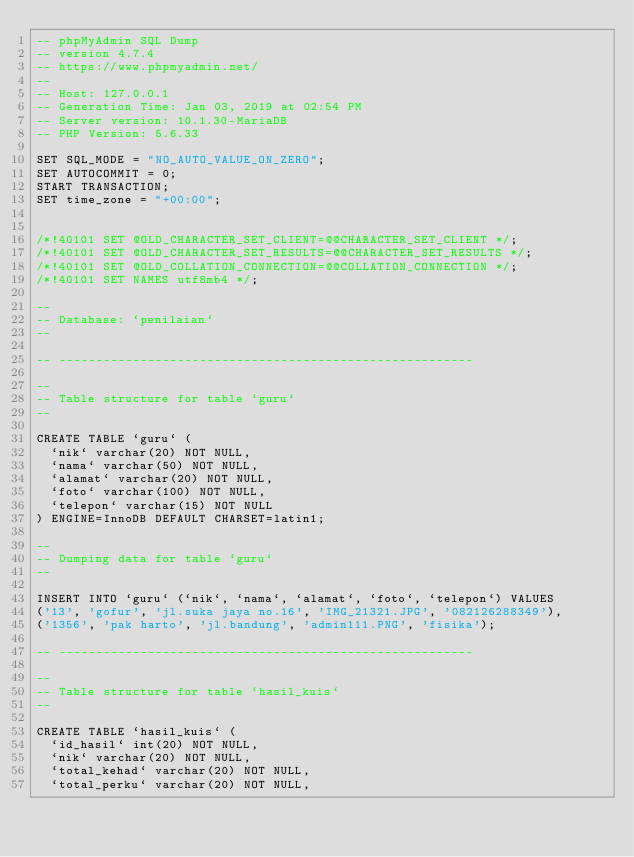Convert code to text. <code><loc_0><loc_0><loc_500><loc_500><_SQL_>-- phpMyAdmin SQL Dump
-- version 4.7.4
-- https://www.phpmyadmin.net/
--
-- Host: 127.0.0.1
-- Generation Time: Jan 03, 2019 at 02:54 PM
-- Server version: 10.1.30-MariaDB
-- PHP Version: 5.6.33

SET SQL_MODE = "NO_AUTO_VALUE_ON_ZERO";
SET AUTOCOMMIT = 0;
START TRANSACTION;
SET time_zone = "+00:00";


/*!40101 SET @OLD_CHARACTER_SET_CLIENT=@@CHARACTER_SET_CLIENT */;
/*!40101 SET @OLD_CHARACTER_SET_RESULTS=@@CHARACTER_SET_RESULTS */;
/*!40101 SET @OLD_COLLATION_CONNECTION=@@COLLATION_CONNECTION */;
/*!40101 SET NAMES utf8mb4 */;

--
-- Database: `penilaian`
--

-- --------------------------------------------------------

--
-- Table structure for table `guru`
--

CREATE TABLE `guru` (
  `nik` varchar(20) NOT NULL,
  `nama` varchar(50) NOT NULL,
  `alamat` varchar(20) NOT NULL,
  `foto` varchar(100) NOT NULL,
  `telepon` varchar(15) NOT NULL
) ENGINE=InnoDB DEFAULT CHARSET=latin1;

--
-- Dumping data for table `guru`
--

INSERT INTO `guru` (`nik`, `nama`, `alamat`, `foto`, `telepon`) VALUES
('13', 'gofur', 'jl.suka jaya no.16', 'IMG_21321.JPG', '082126288349'),
('1356', 'pak harto', 'jl.bandung', 'admin111.PNG', 'fisika');

-- --------------------------------------------------------

--
-- Table structure for table `hasil_kuis`
--

CREATE TABLE `hasil_kuis` (
  `id_hasil` int(20) NOT NULL,
  `nik` varchar(20) NOT NULL,
  `total_kehad` varchar(20) NOT NULL,
  `total_perku` varchar(20) NOT NULL,</code> 